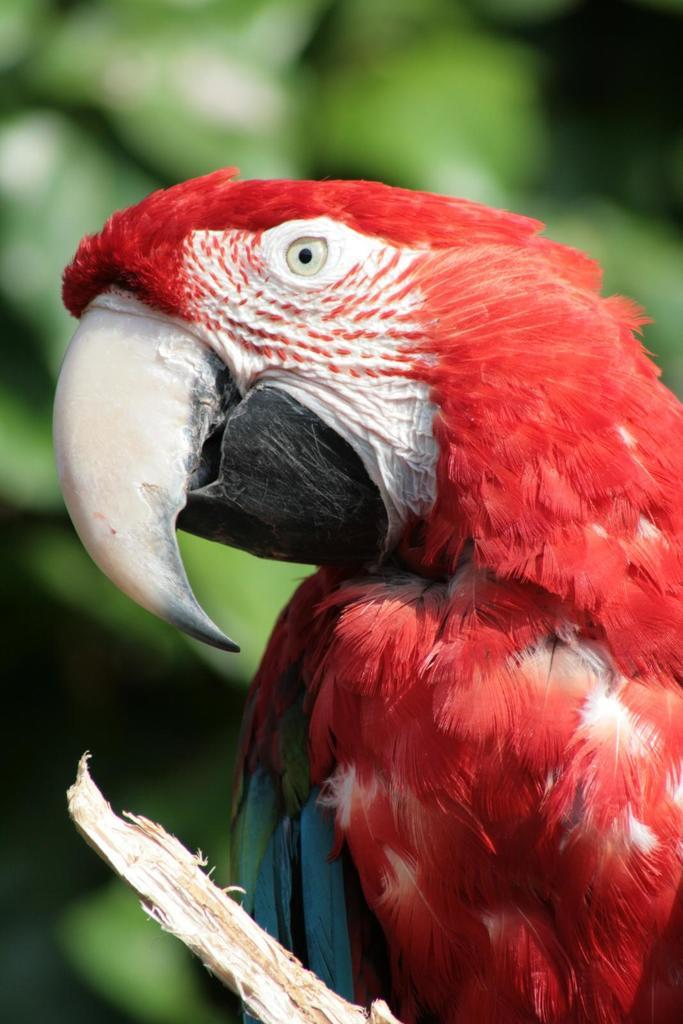What type of animal is in the picture? There is a parrot in the picture. What is the primary color of the parrot? The parrot is predominantly red in color. Are there any other colors on the parrot? Yes, the parrot has blue and green feathers. What can be seen in the picture besides the parrot? There is a tree in the picture. What is visible in the background of the picture? There are trees visible in the background of the picture. What type of door can be seen in the picture? There is no door present in the picture; it features a parrot and trees. What kind of structure is the parrot using as a hole? The parrot is not using any structure as a hole in the picture; it is perched on a branch. 